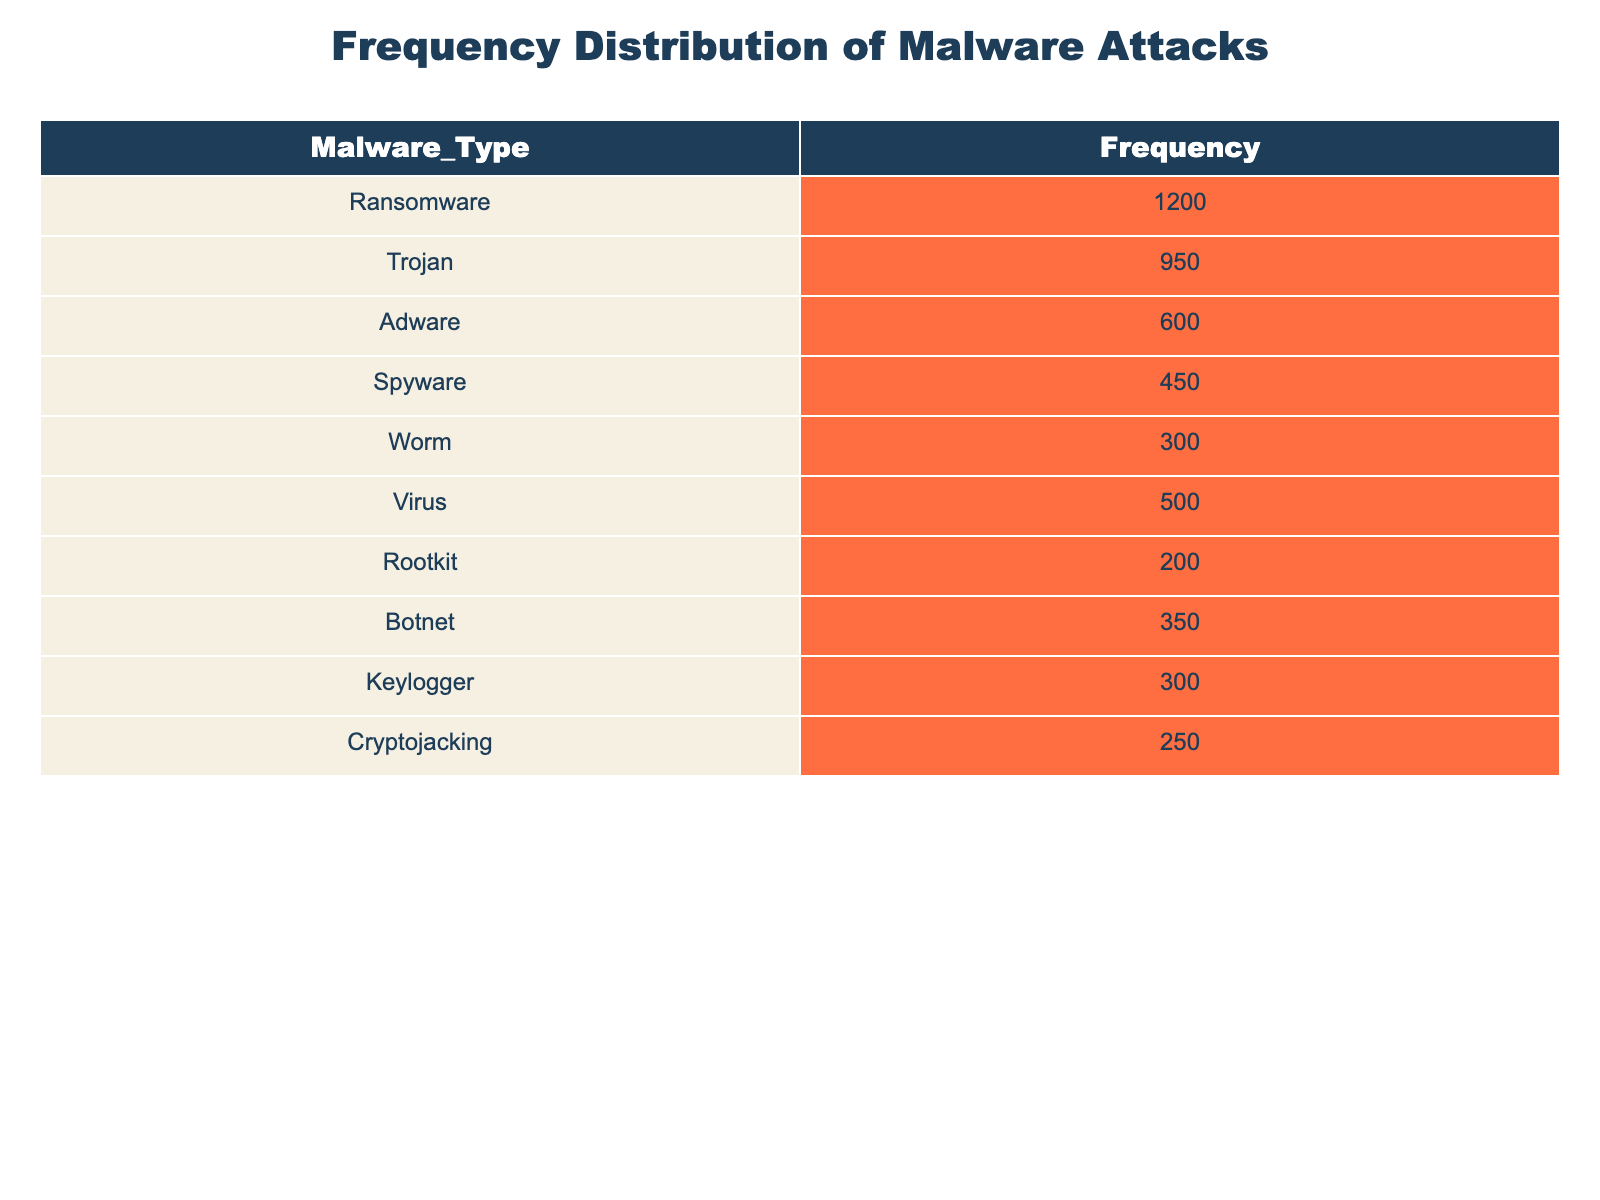What is the frequency of ransomware attacks? The table shows that ransomware has a frequency of 1200 attacks.
Answer: 1200 Which type of malware had the highest frequency? By comparing the frequencies listed, ransomware has the highest frequency at 1200 attacks, followed by Trojan at 950.
Answer: Ransomware What is the total frequency of adware and spyware attacks? Adware has a frequency of 600 and spyware has a frequency of 450. Summing these gives 600 + 450 = 1050.
Answer: 1050 Is the frequency of botnet attacks greater than that of rootkit attacks? Botnet has a frequency of 350 while rootkit has a frequency of 200. Since 350 is greater than 200, the answer is yes.
Answer: Yes What is the average frequency of all types of malware attacks? To find the average, sum the frequencies of all types: 1200 + 950 + 600 + 450 + 300 + 500 + 200 + 350 + 300 + 250 = 4150. There are 10 types of malware, so the average is 4150 / 10 = 415.
Answer: 415 What is the difference between the frequency of virus attacks and keylogger attacks? The frequency of virus attacks is 500 and of keylogger attacks is 300. The difference is 500 - 300 = 200.
Answer: 200 How many malware types have a frequency of less than 400? By examining the table, rootkit (200), worm (300), and cryptojacking (250) all have frequencies below 400. This sums to 3 types.
Answer: 3 Which malware type has a frequency that is closest to the average frequency of all malware attacks? The average frequency calculated previously is 415. The frequencies closest to this are virus (500) and Trojan (950). Virus is closer than Trojan since it is only 85 away compared to 535.
Answer: Virus Does the frequency of Trojan attacks exceed the combined frequency of adware and worm attacks? The frequency of Trojan attacks is 950, adware is 600 and worm is 300. Their combined frequency is 600 + 300 = 900, which is less than 950, so yes, Trojan exceeds the combined frequencies.
Answer: Yes 